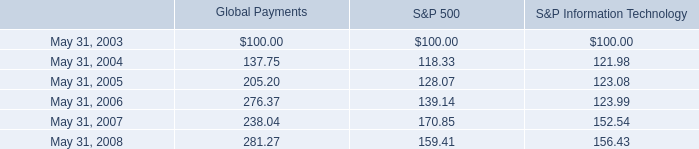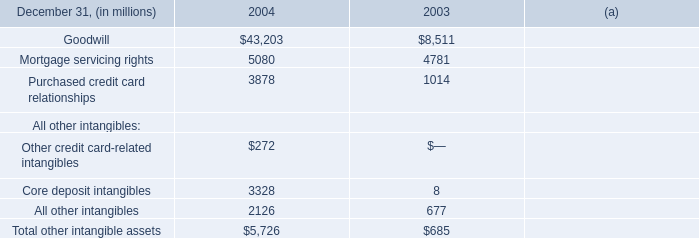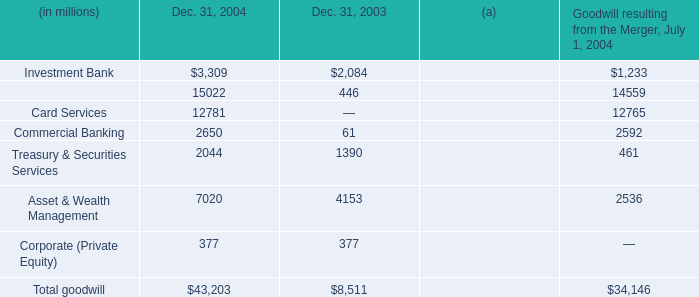In the year with the most Investment Bank, what is the growth rate of Retail Financial Services? 
Computations: ((15022 - 446) / 15022)
Answer: 0.97031. 